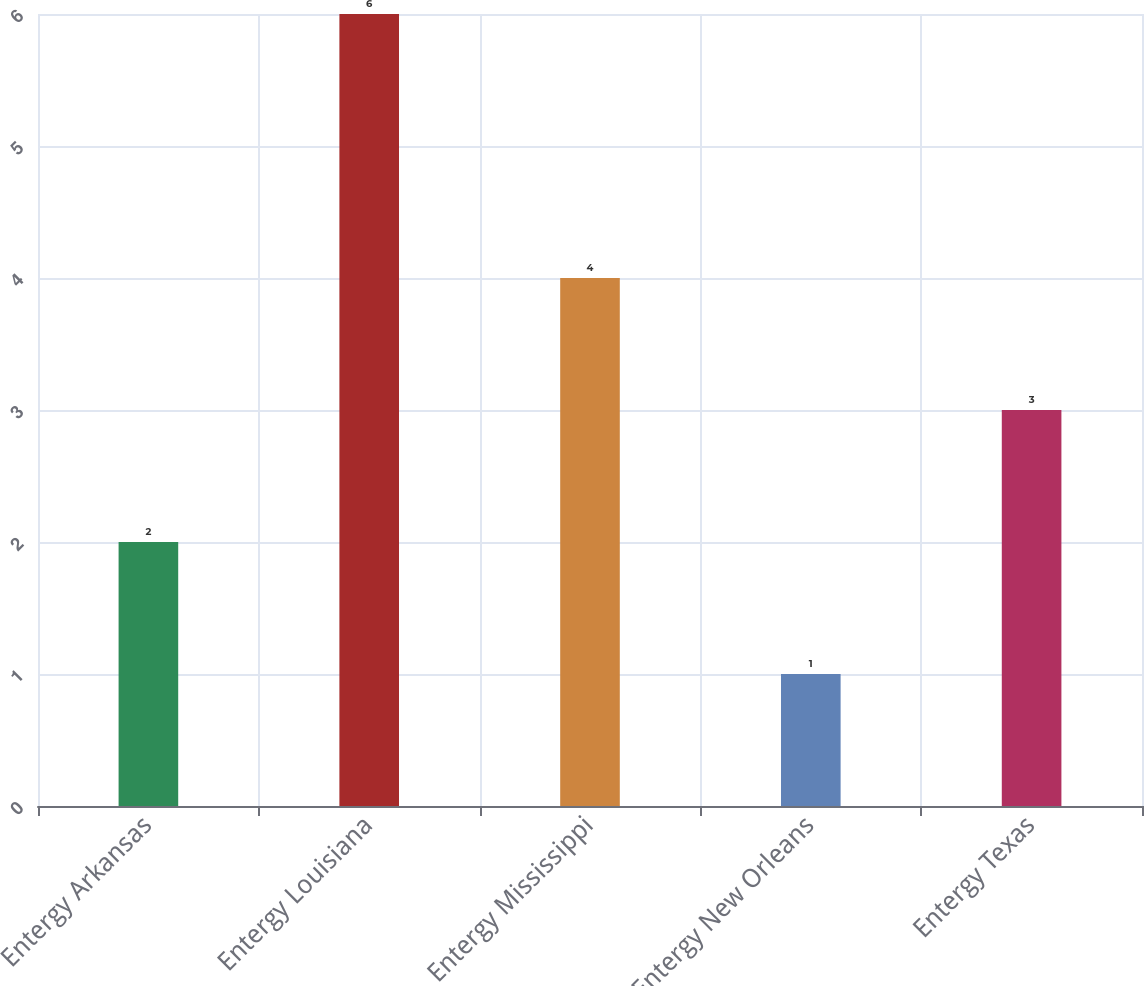Convert chart to OTSL. <chart><loc_0><loc_0><loc_500><loc_500><bar_chart><fcel>Entergy Arkansas<fcel>Entergy Louisiana<fcel>Entergy Mississippi<fcel>Entergy New Orleans<fcel>Entergy Texas<nl><fcel>2<fcel>6<fcel>4<fcel>1<fcel>3<nl></chart> 